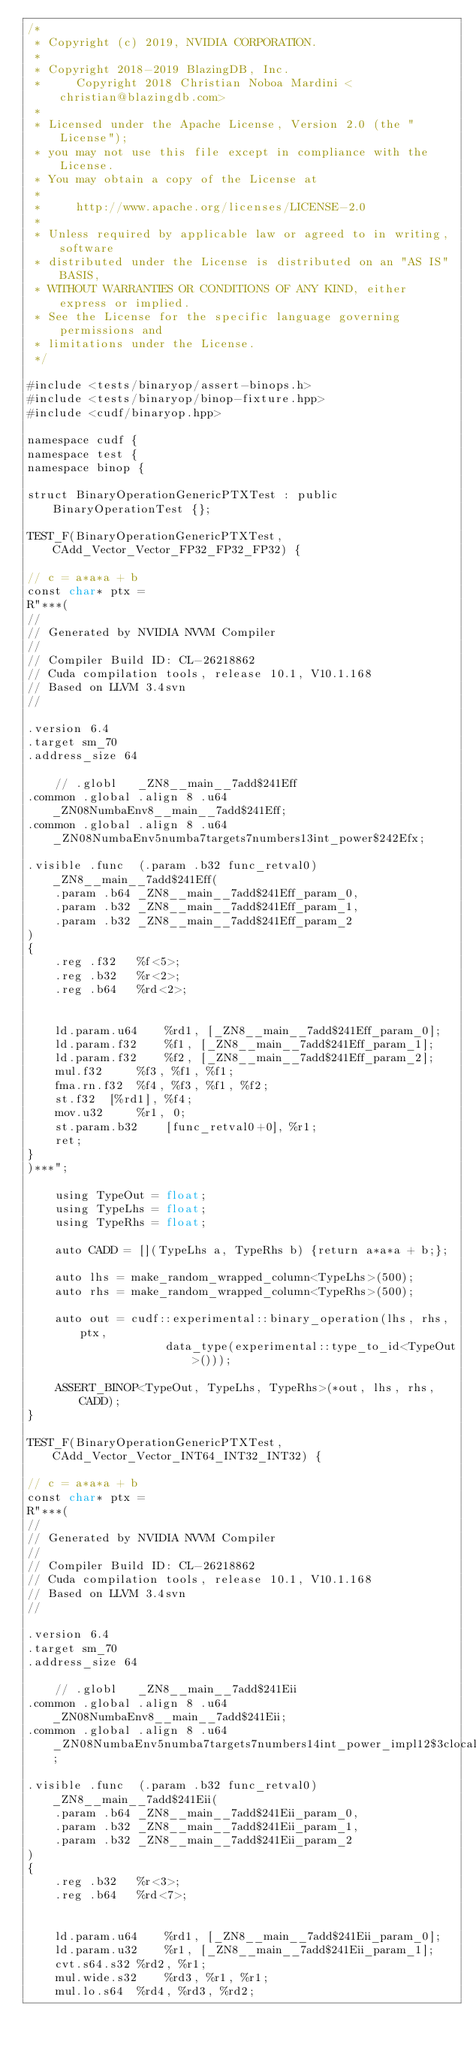<code> <loc_0><loc_0><loc_500><loc_500><_Cuda_>/*
 * Copyright (c) 2019, NVIDIA CORPORATION.
 *
 * Copyright 2018-2019 BlazingDB, Inc.
 *     Copyright 2018 Christian Noboa Mardini <christian@blazingdb.com>
 *
 * Licensed under the Apache License, Version 2.0 (the "License");
 * you may not use this file except in compliance with the License.
 * You may obtain a copy of the License at
 *
 *     http://www.apache.org/licenses/LICENSE-2.0
 *
 * Unless required by applicable law or agreed to in writing, software
 * distributed under the License is distributed on an "AS IS" BASIS,
 * WITHOUT WARRANTIES OR CONDITIONS OF ANY KIND, either express or implied.
 * See the License for the specific language governing permissions and
 * limitations under the License.
 */

#include <tests/binaryop/assert-binops.h>
#include <tests/binaryop/binop-fixture.hpp>
#include <cudf/binaryop.hpp>

namespace cudf {
namespace test {
namespace binop {

struct BinaryOperationGenericPTXTest : public BinaryOperationTest {};

TEST_F(BinaryOperationGenericPTXTest, CAdd_Vector_Vector_FP32_FP32_FP32) {

// c = a*a*a + b
const char* ptx =
R"***(
//
// Generated by NVIDIA NVVM Compiler
//
// Compiler Build ID: CL-26218862
// Cuda compilation tools, release 10.1, V10.1.168
// Based on LLVM 3.4svn
//

.version 6.4
.target sm_70
.address_size 64

	// .globl	_ZN8__main__7add$241Eff
.common .global .align 8 .u64 _ZN08NumbaEnv8__main__7add$241Eff;
.common .global .align 8 .u64 _ZN08NumbaEnv5numba7targets7numbers13int_power$242Efx;

.visible .func  (.param .b32 func_retval0) _ZN8__main__7add$241Eff(
	.param .b64 _ZN8__main__7add$241Eff_param_0,
	.param .b32 _ZN8__main__7add$241Eff_param_1,
	.param .b32 _ZN8__main__7add$241Eff_param_2
)
{
	.reg .f32 	%f<5>;
	.reg .b32 	%r<2>;
	.reg .b64 	%rd<2>;


	ld.param.u64 	%rd1, [_ZN8__main__7add$241Eff_param_0];
	ld.param.f32 	%f1, [_ZN8__main__7add$241Eff_param_1];
	ld.param.f32 	%f2, [_ZN8__main__7add$241Eff_param_2];
	mul.f32 	%f3, %f1, %f1;
	fma.rn.f32 	%f4, %f3, %f1, %f2;
	st.f32 	[%rd1], %f4;
	mov.u32 	%r1, 0;
	st.param.b32	[func_retval0+0], %r1;
	ret;
}
)***";

    using TypeOut = float;
    using TypeLhs = float;
    using TypeRhs = float;

    auto CADD = [](TypeLhs a, TypeRhs b) {return a*a*a + b;};

    auto lhs = make_random_wrapped_column<TypeLhs>(500);
    auto rhs = make_random_wrapped_column<TypeRhs>(500);
    
    auto out = cudf::experimental::binary_operation(lhs, rhs, ptx, 
					data_type(experimental::type_to_id<TypeOut>()));

    ASSERT_BINOP<TypeOut, TypeLhs, TypeRhs>(*out, lhs, rhs, CADD);
}

TEST_F(BinaryOperationGenericPTXTest, CAdd_Vector_Vector_INT64_INT32_INT32) {

// c = a*a*a + b
const char* ptx =
R"***(
//
// Generated by NVIDIA NVVM Compiler
//
// Compiler Build ID: CL-26218862
// Cuda compilation tools, release 10.1, V10.1.168
// Based on LLVM 3.4svn
//

.version 6.4
.target sm_70
.address_size 64

	// .globl	_ZN8__main__7add$241Eii
.common .global .align 8 .u64 _ZN08NumbaEnv8__main__7add$241Eii;
.common .global .align 8 .u64 _ZN08NumbaEnv5numba7targets7numbers14int_power_impl12$3clocals$3e13int_power$242Exx;

.visible .func  (.param .b32 func_retval0) _ZN8__main__7add$241Eii(
	.param .b64 _ZN8__main__7add$241Eii_param_0,
	.param .b32 _ZN8__main__7add$241Eii_param_1,
	.param .b32 _ZN8__main__7add$241Eii_param_2
)
{
	.reg .b32 	%r<3>;
	.reg .b64 	%rd<7>;


	ld.param.u64 	%rd1, [_ZN8__main__7add$241Eii_param_0];
	ld.param.u32 	%r1, [_ZN8__main__7add$241Eii_param_1];
	cvt.s64.s32	%rd2, %r1;
	mul.wide.s32 	%rd3, %r1, %r1;
	mul.lo.s64 	%rd4, %rd3, %rd2;</code> 